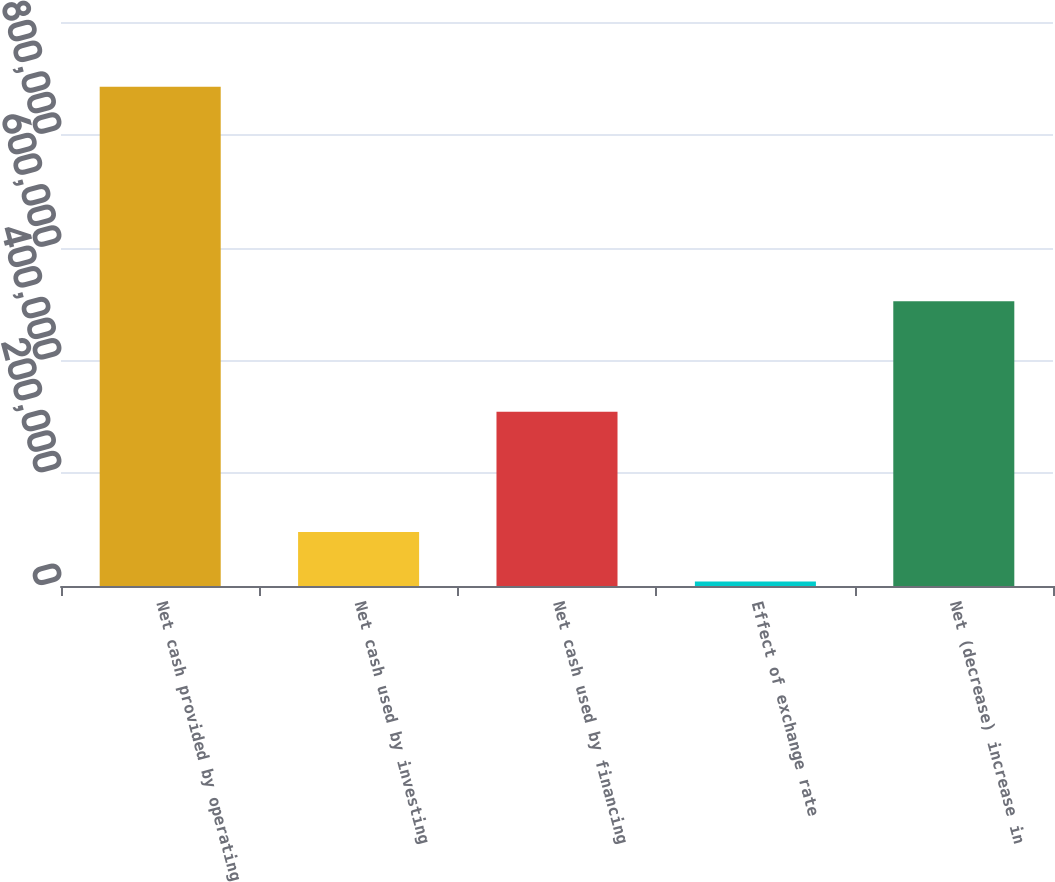Convert chart. <chart><loc_0><loc_0><loc_500><loc_500><bar_chart><fcel>Net cash provided by operating<fcel>Net cash used by investing<fcel>Net cash used by financing<fcel>Effect of exchange rate<fcel>Net (decrease) increase in<nl><fcel>885291<fcel>95538.3<fcel>308944<fcel>7788<fcel>505017<nl></chart> 